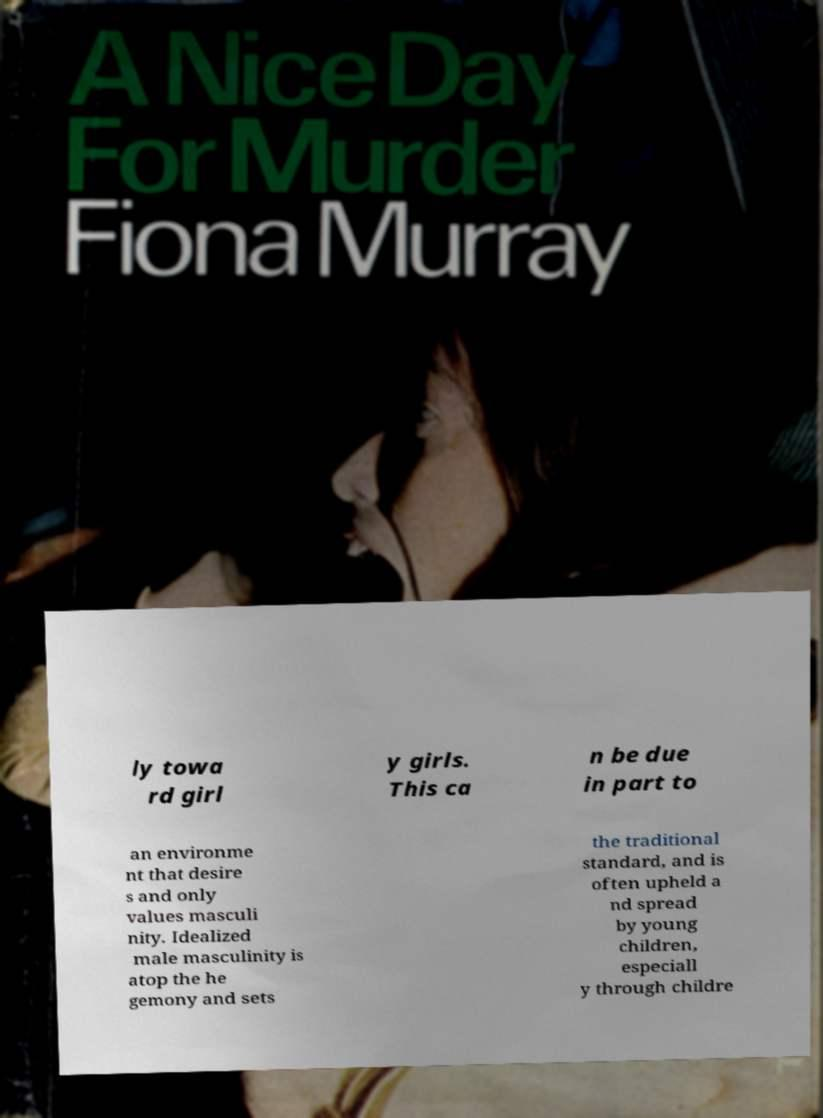Could you assist in decoding the text presented in this image and type it out clearly? ly towa rd girl y girls. This ca n be due in part to an environme nt that desire s and only values masculi nity. Idealized male masculinity is atop the he gemony and sets the traditional standard, and is often upheld a nd spread by young children, especiall y through childre 